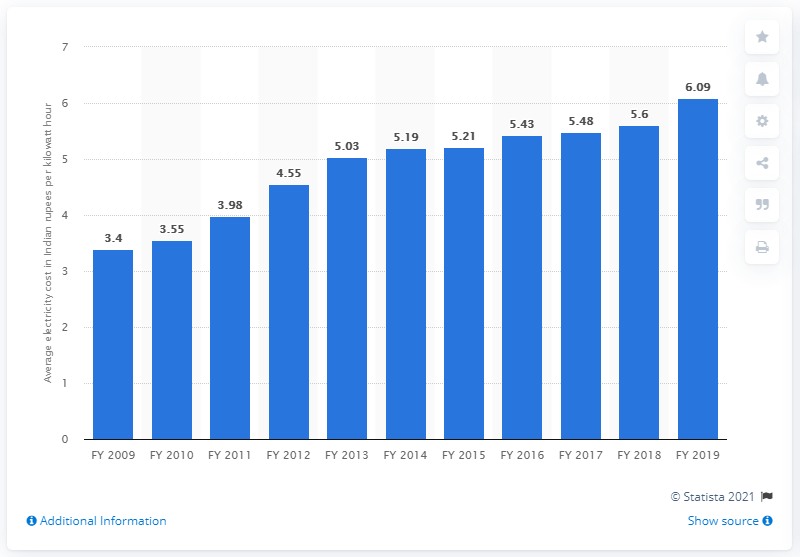Draw attention to some important aspects in this diagram. In 2019, the average cost of state electricity in India was 5.43 rupees per unit. 